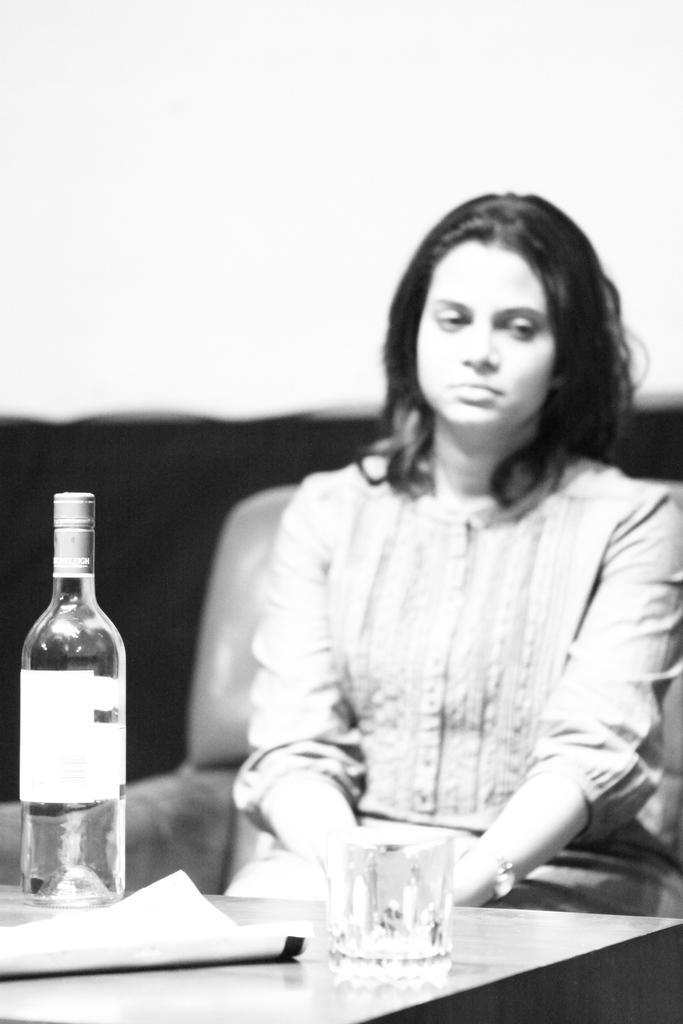What objects are on the table in the image? There is a bottle, a glass, and a paper on the table in the image. What is the woman in the image doing? The woman is seated on a chair in front of the table. Can you describe the woman's position in relation to the table? The woman is seated on a chair in front of the table. What subject is the woman teaching in the image? There is no indication in the image that the woman is teaching, so it cannot be determined from the picture. 